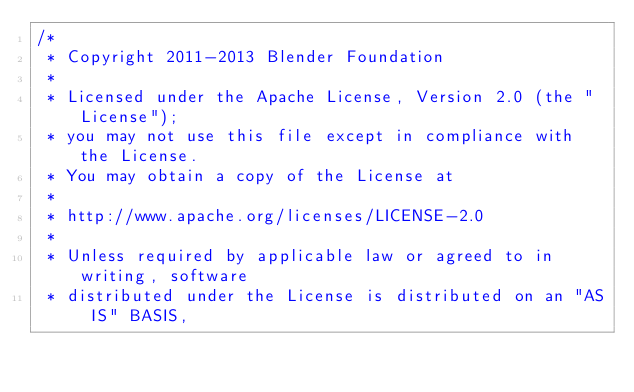<code> <loc_0><loc_0><loc_500><loc_500><_C++_>/*
 * Copyright 2011-2013 Blender Foundation
 *
 * Licensed under the Apache License, Version 2.0 (the "License");
 * you may not use this file except in compliance with the License.
 * You may obtain a copy of the License at
 *
 * http://www.apache.org/licenses/LICENSE-2.0
 *
 * Unless required by applicable law or agreed to in writing, software
 * distributed under the License is distributed on an "AS IS" BASIS,</code> 